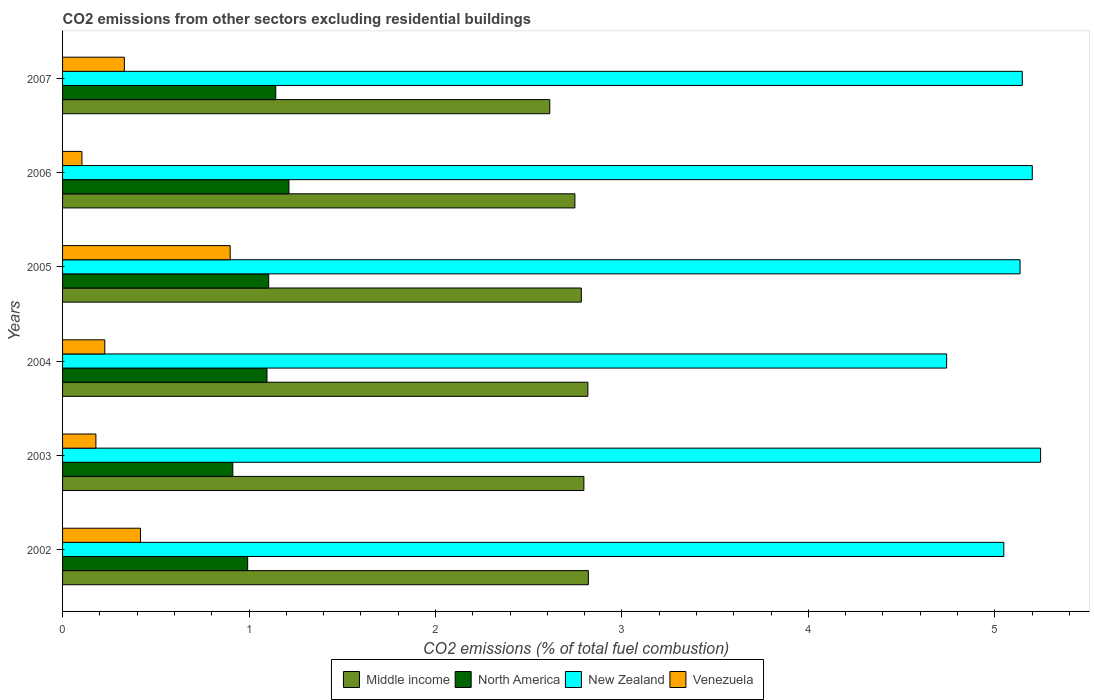How many bars are there on the 5th tick from the bottom?
Give a very brief answer. 4. What is the label of the 1st group of bars from the top?
Your answer should be very brief. 2007. What is the total CO2 emitted in North America in 2006?
Your answer should be very brief. 1.21. Across all years, what is the maximum total CO2 emitted in North America?
Offer a very short reply. 1.21. Across all years, what is the minimum total CO2 emitted in Venezuela?
Ensure brevity in your answer.  0.1. In which year was the total CO2 emitted in Venezuela minimum?
Give a very brief answer. 2006. What is the total total CO2 emitted in Venezuela in the graph?
Provide a succinct answer. 2.16. What is the difference between the total CO2 emitted in Middle income in 2005 and that in 2006?
Your answer should be very brief. 0.03. What is the difference between the total CO2 emitted in Middle income in 2006 and the total CO2 emitted in Venezuela in 2002?
Provide a short and direct response. 2.33. What is the average total CO2 emitted in Venezuela per year?
Offer a terse response. 0.36. In the year 2003, what is the difference between the total CO2 emitted in Venezuela and total CO2 emitted in Middle income?
Make the answer very short. -2.62. In how many years, is the total CO2 emitted in Middle income greater than 4.8 ?
Ensure brevity in your answer.  0. What is the ratio of the total CO2 emitted in New Zealand in 2002 to that in 2003?
Offer a terse response. 0.96. Is the total CO2 emitted in North America in 2003 less than that in 2007?
Make the answer very short. Yes. What is the difference between the highest and the second highest total CO2 emitted in North America?
Give a very brief answer. 0.07. What is the difference between the highest and the lowest total CO2 emitted in North America?
Keep it short and to the point. 0.3. In how many years, is the total CO2 emitted in Venezuela greater than the average total CO2 emitted in Venezuela taken over all years?
Offer a terse response. 2. Is it the case that in every year, the sum of the total CO2 emitted in Venezuela and total CO2 emitted in North America is greater than the sum of total CO2 emitted in Middle income and total CO2 emitted in New Zealand?
Your response must be concise. No. What does the 3rd bar from the top in 2005 represents?
Your answer should be compact. North America. What does the 4th bar from the bottom in 2003 represents?
Your answer should be very brief. Venezuela. Is it the case that in every year, the sum of the total CO2 emitted in Middle income and total CO2 emitted in Venezuela is greater than the total CO2 emitted in North America?
Make the answer very short. Yes. Are the values on the major ticks of X-axis written in scientific E-notation?
Your answer should be compact. No. Does the graph contain any zero values?
Your response must be concise. No. Where does the legend appear in the graph?
Your answer should be compact. Bottom center. How many legend labels are there?
Make the answer very short. 4. How are the legend labels stacked?
Ensure brevity in your answer.  Horizontal. What is the title of the graph?
Ensure brevity in your answer.  CO2 emissions from other sectors excluding residential buildings. What is the label or title of the X-axis?
Offer a terse response. CO2 emissions (% of total fuel combustion). What is the CO2 emissions (% of total fuel combustion) of Middle income in 2002?
Your answer should be compact. 2.82. What is the CO2 emissions (% of total fuel combustion) in North America in 2002?
Provide a short and direct response. 0.99. What is the CO2 emissions (% of total fuel combustion) of New Zealand in 2002?
Your answer should be compact. 5.05. What is the CO2 emissions (% of total fuel combustion) of Venezuela in 2002?
Your answer should be very brief. 0.42. What is the CO2 emissions (% of total fuel combustion) in Middle income in 2003?
Your answer should be very brief. 2.8. What is the CO2 emissions (% of total fuel combustion) in North America in 2003?
Ensure brevity in your answer.  0.91. What is the CO2 emissions (% of total fuel combustion) of New Zealand in 2003?
Offer a terse response. 5.25. What is the CO2 emissions (% of total fuel combustion) of Venezuela in 2003?
Make the answer very short. 0.18. What is the CO2 emissions (% of total fuel combustion) in Middle income in 2004?
Offer a very short reply. 2.82. What is the CO2 emissions (% of total fuel combustion) in North America in 2004?
Your response must be concise. 1.1. What is the CO2 emissions (% of total fuel combustion) in New Zealand in 2004?
Make the answer very short. 4.74. What is the CO2 emissions (% of total fuel combustion) in Venezuela in 2004?
Give a very brief answer. 0.23. What is the CO2 emissions (% of total fuel combustion) of Middle income in 2005?
Your response must be concise. 2.78. What is the CO2 emissions (% of total fuel combustion) of North America in 2005?
Provide a succinct answer. 1.11. What is the CO2 emissions (% of total fuel combustion) of New Zealand in 2005?
Offer a terse response. 5.14. What is the CO2 emissions (% of total fuel combustion) of Venezuela in 2005?
Ensure brevity in your answer.  0.9. What is the CO2 emissions (% of total fuel combustion) in Middle income in 2006?
Your answer should be very brief. 2.75. What is the CO2 emissions (% of total fuel combustion) in North America in 2006?
Provide a short and direct response. 1.21. What is the CO2 emissions (% of total fuel combustion) of New Zealand in 2006?
Your response must be concise. 5.2. What is the CO2 emissions (% of total fuel combustion) of Venezuela in 2006?
Give a very brief answer. 0.1. What is the CO2 emissions (% of total fuel combustion) in Middle income in 2007?
Keep it short and to the point. 2.61. What is the CO2 emissions (% of total fuel combustion) of North America in 2007?
Your answer should be very brief. 1.14. What is the CO2 emissions (% of total fuel combustion) in New Zealand in 2007?
Your answer should be compact. 5.15. What is the CO2 emissions (% of total fuel combustion) in Venezuela in 2007?
Keep it short and to the point. 0.33. Across all years, what is the maximum CO2 emissions (% of total fuel combustion) of Middle income?
Make the answer very short. 2.82. Across all years, what is the maximum CO2 emissions (% of total fuel combustion) in North America?
Provide a short and direct response. 1.21. Across all years, what is the maximum CO2 emissions (% of total fuel combustion) in New Zealand?
Your response must be concise. 5.25. Across all years, what is the maximum CO2 emissions (% of total fuel combustion) of Venezuela?
Your response must be concise. 0.9. Across all years, what is the minimum CO2 emissions (% of total fuel combustion) of Middle income?
Provide a short and direct response. 2.61. Across all years, what is the minimum CO2 emissions (% of total fuel combustion) in North America?
Ensure brevity in your answer.  0.91. Across all years, what is the minimum CO2 emissions (% of total fuel combustion) of New Zealand?
Provide a succinct answer. 4.74. Across all years, what is the minimum CO2 emissions (% of total fuel combustion) in Venezuela?
Provide a succinct answer. 0.1. What is the total CO2 emissions (% of total fuel combustion) in Middle income in the graph?
Provide a succinct answer. 16.58. What is the total CO2 emissions (% of total fuel combustion) of North America in the graph?
Make the answer very short. 6.47. What is the total CO2 emissions (% of total fuel combustion) in New Zealand in the graph?
Your response must be concise. 30.52. What is the total CO2 emissions (% of total fuel combustion) in Venezuela in the graph?
Provide a short and direct response. 2.16. What is the difference between the CO2 emissions (% of total fuel combustion) in Middle income in 2002 and that in 2003?
Your answer should be very brief. 0.02. What is the difference between the CO2 emissions (% of total fuel combustion) in North America in 2002 and that in 2003?
Offer a terse response. 0.08. What is the difference between the CO2 emissions (% of total fuel combustion) of New Zealand in 2002 and that in 2003?
Offer a very short reply. -0.2. What is the difference between the CO2 emissions (% of total fuel combustion) of Venezuela in 2002 and that in 2003?
Ensure brevity in your answer.  0.24. What is the difference between the CO2 emissions (% of total fuel combustion) of Middle income in 2002 and that in 2004?
Give a very brief answer. 0. What is the difference between the CO2 emissions (% of total fuel combustion) in North America in 2002 and that in 2004?
Offer a terse response. -0.1. What is the difference between the CO2 emissions (% of total fuel combustion) in New Zealand in 2002 and that in 2004?
Ensure brevity in your answer.  0.31. What is the difference between the CO2 emissions (% of total fuel combustion) in Venezuela in 2002 and that in 2004?
Your answer should be very brief. 0.19. What is the difference between the CO2 emissions (% of total fuel combustion) in Middle income in 2002 and that in 2005?
Provide a succinct answer. 0.04. What is the difference between the CO2 emissions (% of total fuel combustion) of North America in 2002 and that in 2005?
Make the answer very short. -0.11. What is the difference between the CO2 emissions (% of total fuel combustion) of New Zealand in 2002 and that in 2005?
Keep it short and to the point. -0.09. What is the difference between the CO2 emissions (% of total fuel combustion) of Venezuela in 2002 and that in 2005?
Ensure brevity in your answer.  -0.48. What is the difference between the CO2 emissions (% of total fuel combustion) of Middle income in 2002 and that in 2006?
Make the answer very short. 0.07. What is the difference between the CO2 emissions (% of total fuel combustion) in North America in 2002 and that in 2006?
Your answer should be compact. -0.22. What is the difference between the CO2 emissions (% of total fuel combustion) in New Zealand in 2002 and that in 2006?
Make the answer very short. -0.15. What is the difference between the CO2 emissions (% of total fuel combustion) in Venezuela in 2002 and that in 2006?
Provide a succinct answer. 0.31. What is the difference between the CO2 emissions (% of total fuel combustion) in Middle income in 2002 and that in 2007?
Offer a terse response. 0.21. What is the difference between the CO2 emissions (% of total fuel combustion) in North America in 2002 and that in 2007?
Your answer should be very brief. -0.15. What is the difference between the CO2 emissions (% of total fuel combustion) in New Zealand in 2002 and that in 2007?
Keep it short and to the point. -0.1. What is the difference between the CO2 emissions (% of total fuel combustion) in Venezuela in 2002 and that in 2007?
Give a very brief answer. 0.09. What is the difference between the CO2 emissions (% of total fuel combustion) of Middle income in 2003 and that in 2004?
Your answer should be very brief. -0.02. What is the difference between the CO2 emissions (% of total fuel combustion) of North America in 2003 and that in 2004?
Offer a very short reply. -0.18. What is the difference between the CO2 emissions (% of total fuel combustion) of New Zealand in 2003 and that in 2004?
Make the answer very short. 0.5. What is the difference between the CO2 emissions (% of total fuel combustion) of Venezuela in 2003 and that in 2004?
Keep it short and to the point. -0.05. What is the difference between the CO2 emissions (% of total fuel combustion) of Middle income in 2003 and that in 2005?
Give a very brief answer. 0.01. What is the difference between the CO2 emissions (% of total fuel combustion) in North America in 2003 and that in 2005?
Offer a very short reply. -0.19. What is the difference between the CO2 emissions (% of total fuel combustion) of New Zealand in 2003 and that in 2005?
Give a very brief answer. 0.11. What is the difference between the CO2 emissions (% of total fuel combustion) of Venezuela in 2003 and that in 2005?
Provide a short and direct response. -0.72. What is the difference between the CO2 emissions (% of total fuel combustion) in Middle income in 2003 and that in 2006?
Keep it short and to the point. 0.05. What is the difference between the CO2 emissions (% of total fuel combustion) of North America in 2003 and that in 2006?
Ensure brevity in your answer.  -0.3. What is the difference between the CO2 emissions (% of total fuel combustion) of New Zealand in 2003 and that in 2006?
Offer a very short reply. 0.04. What is the difference between the CO2 emissions (% of total fuel combustion) in Venezuela in 2003 and that in 2006?
Offer a very short reply. 0.07. What is the difference between the CO2 emissions (% of total fuel combustion) of Middle income in 2003 and that in 2007?
Provide a succinct answer. 0.18. What is the difference between the CO2 emissions (% of total fuel combustion) of North America in 2003 and that in 2007?
Give a very brief answer. -0.23. What is the difference between the CO2 emissions (% of total fuel combustion) of New Zealand in 2003 and that in 2007?
Make the answer very short. 0.1. What is the difference between the CO2 emissions (% of total fuel combustion) of Venezuela in 2003 and that in 2007?
Your answer should be compact. -0.15. What is the difference between the CO2 emissions (% of total fuel combustion) of Middle income in 2004 and that in 2005?
Provide a short and direct response. 0.04. What is the difference between the CO2 emissions (% of total fuel combustion) of North America in 2004 and that in 2005?
Keep it short and to the point. -0.01. What is the difference between the CO2 emissions (% of total fuel combustion) in New Zealand in 2004 and that in 2005?
Keep it short and to the point. -0.39. What is the difference between the CO2 emissions (% of total fuel combustion) in Venezuela in 2004 and that in 2005?
Offer a very short reply. -0.67. What is the difference between the CO2 emissions (% of total fuel combustion) in Middle income in 2004 and that in 2006?
Keep it short and to the point. 0.07. What is the difference between the CO2 emissions (% of total fuel combustion) in North America in 2004 and that in 2006?
Provide a short and direct response. -0.12. What is the difference between the CO2 emissions (% of total fuel combustion) of New Zealand in 2004 and that in 2006?
Offer a terse response. -0.46. What is the difference between the CO2 emissions (% of total fuel combustion) of Venezuela in 2004 and that in 2006?
Provide a short and direct response. 0.12. What is the difference between the CO2 emissions (% of total fuel combustion) in Middle income in 2004 and that in 2007?
Keep it short and to the point. 0.2. What is the difference between the CO2 emissions (% of total fuel combustion) in North America in 2004 and that in 2007?
Your answer should be very brief. -0.05. What is the difference between the CO2 emissions (% of total fuel combustion) in New Zealand in 2004 and that in 2007?
Offer a very short reply. -0.41. What is the difference between the CO2 emissions (% of total fuel combustion) of Venezuela in 2004 and that in 2007?
Provide a short and direct response. -0.1. What is the difference between the CO2 emissions (% of total fuel combustion) in Middle income in 2005 and that in 2006?
Give a very brief answer. 0.03. What is the difference between the CO2 emissions (% of total fuel combustion) in North America in 2005 and that in 2006?
Keep it short and to the point. -0.11. What is the difference between the CO2 emissions (% of total fuel combustion) in New Zealand in 2005 and that in 2006?
Your answer should be very brief. -0.07. What is the difference between the CO2 emissions (% of total fuel combustion) of Venezuela in 2005 and that in 2006?
Give a very brief answer. 0.8. What is the difference between the CO2 emissions (% of total fuel combustion) of Middle income in 2005 and that in 2007?
Your answer should be compact. 0.17. What is the difference between the CO2 emissions (% of total fuel combustion) in North America in 2005 and that in 2007?
Your answer should be compact. -0.04. What is the difference between the CO2 emissions (% of total fuel combustion) in New Zealand in 2005 and that in 2007?
Provide a succinct answer. -0.01. What is the difference between the CO2 emissions (% of total fuel combustion) in Venezuela in 2005 and that in 2007?
Offer a terse response. 0.57. What is the difference between the CO2 emissions (% of total fuel combustion) in Middle income in 2006 and that in 2007?
Make the answer very short. 0.13. What is the difference between the CO2 emissions (% of total fuel combustion) of North America in 2006 and that in 2007?
Keep it short and to the point. 0.07. What is the difference between the CO2 emissions (% of total fuel combustion) of New Zealand in 2006 and that in 2007?
Provide a short and direct response. 0.05. What is the difference between the CO2 emissions (% of total fuel combustion) of Venezuela in 2006 and that in 2007?
Your response must be concise. -0.23. What is the difference between the CO2 emissions (% of total fuel combustion) in Middle income in 2002 and the CO2 emissions (% of total fuel combustion) in North America in 2003?
Provide a succinct answer. 1.91. What is the difference between the CO2 emissions (% of total fuel combustion) in Middle income in 2002 and the CO2 emissions (% of total fuel combustion) in New Zealand in 2003?
Your response must be concise. -2.43. What is the difference between the CO2 emissions (% of total fuel combustion) in Middle income in 2002 and the CO2 emissions (% of total fuel combustion) in Venezuela in 2003?
Your response must be concise. 2.64. What is the difference between the CO2 emissions (% of total fuel combustion) of North America in 2002 and the CO2 emissions (% of total fuel combustion) of New Zealand in 2003?
Your answer should be very brief. -4.25. What is the difference between the CO2 emissions (% of total fuel combustion) of North America in 2002 and the CO2 emissions (% of total fuel combustion) of Venezuela in 2003?
Ensure brevity in your answer.  0.81. What is the difference between the CO2 emissions (% of total fuel combustion) in New Zealand in 2002 and the CO2 emissions (% of total fuel combustion) in Venezuela in 2003?
Provide a short and direct response. 4.87. What is the difference between the CO2 emissions (% of total fuel combustion) of Middle income in 2002 and the CO2 emissions (% of total fuel combustion) of North America in 2004?
Offer a terse response. 1.72. What is the difference between the CO2 emissions (% of total fuel combustion) of Middle income in 2002 and the CO2 emissions (% of total fuel combustion) of New Zealand in 2004?
Ensure brevity in your answer.  -1.92. What is the difference between the CO2 emissions (% of total fuel combustion) of Middle income in 2002 and the CO2 emissions (% of total fuel combustion) of Venezuela in 2004?
Provide a short and direct response. 2.59. What is the difference between the CO2 emissions (% of total fuel combustion) in North America in 2002 and the CO2 emissions (% of total fuel combustion) in New Zealand in 2004?
Keep it short and to the point. -3.75. What is the difference between the CO2 emissions (% of total fuel combustion) in North America in 2002 and the CO2 emissions (% of total fuel combustion) in Venezuela in 2004?
Offer a very short reply. 0.77. What is the difference between the CO2 emissions (% of total fuel combustion) in New Zealand in 2002 and the CO2 emissions (% of total fuel combustion) in Venezuela in 2004?
Your answer should be very brief. 4.82. What is the difference between the CO2 emissions (% of total fuel combustion) of Middle income in 2002 and the CO2 emissions (% of total fuel combustion) of North America in 2005?
Provide a short and direct response. 1.71. What is the difference between the CO2 emissions (% of total fuel combustion) of Middle income in 2002 and the CO2 emissions (% of total fuel combustion) of New Zealand in 2005?
Keep it short and to the point. -2.32. What is the difference between the CO2 emissions (% of total fuel combustion) in Middle income in 2002 and the CO2 emissions (% of total fuel combustion) in Venezuela in 2005?
Make the answer very short. 1.92. What is the difference between the CO2 emissions (% of total fuel combustion) in North America in 2002 and the CO2 emissions (% of total fuel combustion) in New Zealand in 2005?
Your answer should be compact. -4.14. What is the difference between the CO2 emissions (% of total fuel combustion) of North America in 2002 and the CO2 emissions (% of total fuel combustion) of Venezuela in 2005?
Your response must be concise. 0.09. What is the difference between the CO2 emissions (% of total fuel combustion) in New Zealand in 2002 and the CO2 emissions (% of total fuel combustion) in Venezuela in 2005?
Ensure brevity in your answer.  4.15. What is the difference between the CO2 emissions (% of total fuel combustion) in Middle income in 2002 and the CO2 emissions (% of total fuel combustion) in North America in 2006?
Make the answer very short. 1.61. What is the difference between the CO2 emissions (% of total fuel combustion) in Middle income in 2002 and the CO2 emissions (% of total fuel combustion) in New Zealand in 2006?
Provide a short and direct response. -2.38. What is the difference between the CO2 emissions (% of total fuel combustion) in Middle income in 2002 and the CO2 emissions (% of total fuel combustion) in Venezuela in 2006?
Your answer should be compact. 2.72. What is the difference between the CO2 emissions (% of total fuel combustion) in North America in 2002 and the CO2 emissions (% of total fuel combustion) in New Zealand in 2006?
Offer a terse response. -4.21. What is the difference between the CO2 emissions (% of total fuel combustion) in New Zealand in 2002 and the CO2 emissions (% of total fuel combustion) in Venezuela in 2006?
Provide a succinct answer. 4.94. What is the difference between the CO2 emissions (% of total fuel combustion) in Middle income in 2002 and the CO2 emissions (% of total fuel combustion) in North America in 2007?
Give a very brief answer. 1.68. What is the difference between the CO2 emissions (% of total fuel combustion) of Middle income in 2002 and the CO2 emissions (% of total fuel combustion) of New Zealand in 2007?
Offer a very short reply. -2.33. What is the difference between the CO2 emissions (% of total fuel combustion) in Middle income in 2002 and the CO2 emissions (% of total fuel combustion) in Venezuela in 2007?
Your answer should be compact. 2.49. What is the difference between the CO2 emissions (% of total fuel combustion) in North America in 2002 and the CO2 emissions (% of total fuel combustion) in New Zealand in 2007?
Ensure brevity in your answer.  -4.15. What is the difference between the CO2 emissions (% of total fuel combustion) of North America in 2002 and the CO2 emissions (% of total fuel combustion) of Venezuela in 2007?
Ensure brevity in your answer.  0.66. What is the difference between the CO2 emissions (% of total fuel combustion) of New Zealand in 2002 and the CO2 emissions (% of total fuel combustion) of Venezuela in 2007?
Provide a succinct answer. 4.72. What is the difference between the CO2 emissions (% of total fuel combustion) in Middle income in 2003 and the CO2 emissions (% of total fuel combustion) in North America in 2004?
Provide a succinct answer. 1.7. What is the difference between the CO2 emissions (% of total fuel combustion) in Middle income in 2003 and the CO2 emissions (% of total fuel combustion) in New Zealand in 2004?
Offer a very short reply. -1.95. What is the difference between the CO2 emissions (% of total fuel combustion) in Middle income in 2003 and the CO2 emissions (% of total fuel combustion) in Venezuela in 2004?
Provide a succinct answer. 2.57. What is the difference between the CO2 emissions (% of total fuel combustion) of North America in 2003 and the CO2 emissions (% of total fuel combustion) of New Zealand in 2004?
Give a very brief answer. -3.83. What is the difference between the CO2 emissions (% of total fuel combustion) in North America in 2003 and the CO2 emissions (% of total fuel combustion) in Venezuela in 2004?
Your response must be concise. 0.69. What is the difference between the CO2 emissions (% of total fuel combustion) of New Zealand in 2003 and the CO2 emissions (% of total fuel combustion) of Venezuela in 2004?
Ensure brevity in your answer.  5.02. What is the difference between the CO2 emissions (% of total fuel combustion) in Middle income in 2003 and the CO2 emissions (% of total fuel combustion) in North America in 2005?
Offer a terse response. 1.69. What is the difference between the CO2 emissions (% of total fuel combustion) of Middle income in 2003 and the CO2 emissions (% of total fuel combustion) of New Zealand in 2005?
Your answer should be very brief. -2.34. What is the difference between the CO2 emissions (% of total fuel combustion) of Middle income in 2003 and the CO2 emissions (% of total fuel combustion) of Venezuela in 2005?
Ensure brevity in your answer.  1.9. What is the difference between the CO2 emissions (% of total fuel combustion) of North America in 2003 and the CO2 emissions (% of total fuel combustion) of New Zealand in 2005?
Make the answer very short. -4.22. What is the difference between the CO2 emissions (% of total fuel combustion) in North America in 2003 and the CO2 emissions (% of total fuel combustion) in Venezuela in 2005?
Provide a short and direct response. 0.01. What is the difference between the CO2 emissions (% of total fuel combustion) of New Zealand in 2003 and the CO2 emissions (% of total fuel combustion) of Venezuela in 2005?
Keep it short and to the point. 4.35. What is the difference between the CO2 emissions (% of total fuel combustion) in Middle income in 2003 and the CO2 emissions (% of total fuel combustion) in North America in 2006?
Offer a terse response. 1.58. What is the difference between the CO2 emissions (% of total fuel combustion) of Middle income in 2003 and the CO2 emissions (% of total fuel combustion) of New Zealand in 2006?
Provide a short and direct response. -2.41. What is the difference between the CO2 emissions (% of total fuel combustion) in Middle income in 2003 and the CO2 emissions (% of total fuel combustion) in Venezuela in 2006?
Provide a succinct answer. 2.69. What is the difference between the CO2 emissions (% of total fuel combustion) of North America in 2003 and the CO2 emissions (% of total fuel combustion) of New Zealand in 2006?
Ensure brevity in your answer.  -4.29. What is the difference between the CO2 emissions (% of total fuel combustion) of North America in 2003 and the CO2 emissions (% of total fuel combustion) of Venezuela in 2006?
Offer a very short reply. 0.81. What is the difference between the CO2 emissions (% of total fuel combustion) of New Zealand in 2003 and the CO2 emissions (% of total fuel combustion) of Venezuela in 2006?
Ensure brevity in your answer.  5.14. What is the difference between the CO2 emissions (% of total fuel combustion) of Middle income in 2003 and the CO2 emissions (% of total fuel combustion) of North America in 2007?
Your answer should be compact. 1.65. What is the difference between the CO2 emissions (% of total fuel combustion) of Middle income in 2003 and the CO2 emissions (% of total fuel combustion) of New Zealand in 2007?
Provide a short and direct response. -2.35. What is the difference between the CO2 emissions (% of total fuel combustion) of Middle income in 2003 and the CO2 emissions (% of total fuel combustion) of Venezuela in 2007?
Your response must be concise. 2.46. What is the difference between the CO2 emissions (% of total fuel combustion) of North America in 2003 and the CO2 emissions (% of total fuel combustion) of New Zealand in 2007?
Offer a terse response. -4.23. What is the difference between the CO2 emissions (% of total fuel combustion) of North America in 2003 and the CO2 emissions (% of total fuel combustion) of Venezuela in 2007?
Offer a terse response. 0.58. What is the difference between the CO2 emissions (% of total fuel combustion) of New Zealand in 2003 and the CO2 emissions (% of total fuel combustion) of Venezuela in 2007?
Ensure brevity in your answer.  4.91. What is the difference between the CO2 emissions (% of total fuel combustion) in Middle income in 2004 and the CO2 emissions (% of total fuel combustion) in North America in 2005?
Give a very brief answer. 1.71. What is the difference between the CO2 emissions (% of total fuel combustion) of Middle income in 2004 and the CO2 emissions (% of total fuel combustion) of New Zealand in 2005?
Provide a succinct answer. -2.32. What is the difference between the CO2 emissions (% of total fuel combustion) of Middle income in 2004 and the CO2 emissions (% of total fuel combustion) of Venezuela in 2005?
Your answer should be compact. 1.92. What is the difference between the CO2 emissions (% of total fuel combustion) of North America in 2004 and the CO2 emissions (% of total fuel combustion) of New Zealand in 2005?
Your answer should be compact. -4.04. What is the difference between the CO2 emissions (% of total fuel combustion) of North America in 2004 and the CO2 emissions (% of total fuel combustion) of Venezuela in 2005?
Make the answer very short. 0.2. What is the difference between the CO2 emissions (% of total fuel combustion) of New Zealand in 2004 and the CO2 emissions (% of total fuel combustion) of Venezuela in 2005?
Provide a short and direct response. 3.84. What is the difference between the CO2 emissions (% of total fuel combustion) in Middle income in 2004 and the CO2 emissions (% of total fuel combustion) in North America in 2006?
Keep it short and to the point. 1.6. What is the difference between the CO2 emissions (% of total fuel combustion) of Middle income in 2004 and the CO2 emissions (% of total fuel combustion) of New Zealand in 2006?
Offer a terse response. -2.38. What is the difference between the CO2 emissions (% of total fuel combustion) in Middle income in 2004 and the CO2 emissions (% of total fuel combustion) in Venezuela in 2006?
Make the answer very short. 2.71. What is the difference between the CO2 emissions (% of total fuel combustion) of North America in 2004 and the CO2 emissions (% of total fuel combustion) of New Zealand in 2006?
Ensure brevity in your answer.  -4.1. What is the difference between the CO2 emissions (% of total fuel combustion) in North America in 2004 and the CO2 emissions (% of total fuel combustion) in Venezuela in 2006?
Your answer should be very brief. 0.99. What is the difference between the CO2 emissions (% of total fuel combustion) of New Zealand in 2004 and the CO2 emissions (% of total fuel combustion) of Venezuela in 2006?
Make the answer very short. 4.64. What is the difference between the CO2 emissions (% of total fuel combustion) in Middle income in 2004 and the CO2 emissions (% of total fuel combustion) in North America in 2007?
Provide a succinct answer. 1.67. What is the difference between the CO2 emissions (% of total fuel combustion) of Middle income in 2004 and the CO2 emissions (% of total fuel combustion) of New Zealand in 2007?
Make the answer very short. -2.33. What is the difference between the CO2 emissions (% of total fuel combustion) in Middle income in 2004 and the CO2 emissions (% of total fuel combustion) in Venezuela in 2007?
Ensure brevity in your answer.  2.49. What is the difference between the CO2 emissions (% of total fuel combustion) in North America in 2004 and the CO2 emissions (% of total fuel combustion) in New Zealand in 2007?
Provide a short and direct response. -4.05. What is the difference between the CO2 emissions (% of total fuel combustion) in North America in 2004 and the CO2 emissions (% of total fuel combustion) in Venezuela in 2007?
Your answer should be compact. 0.77. What is the difference between the CO2 emissions (% of total fuel combustion) in New Zealand in 2004 and the CO2 emissions (% of total fuel combustion) in Venezuela in 2007?
Offer a very short reply. 4.41. What is the difference between the CO2 emissions (% of total fuel combustion) of Middle income in 2005 and the CO2 emissions (% of total fuel combustion) of North America in 2006?
Make the answer very short. 1.57. What is the difference between the CO2 emissions (% of total fuel combustion) of Middle income in 2005 and the CO2 emissions (% of total fuel combustion) of New Zealand in 2006?
Offer a terse response. -2.42. What is the difference between the CO2 emissions (% of total fuel combustion) of Middle income in 2005 and the CO2 emissions (% of total fuel combustion) of Venezuela in 2006?
Give a very brief answer. 2.68. What is the difference between the CO2 emissions (% of total fuel combustion) of North America in 2005 and the CO2 emissions (% of total fuel combustion) of New Zealand in 2006?
Offer a very short reply. -4.1. What is the difference between the CO2 emissions (% of total fuel combustion) in North America in 2005 and the CO2 emissions (% of total fuel combustion) in Venezuela in 2006?
Ensure brevity in your answer.  1. What is the difference between the CO2 emissions (% of total fuel combustion) in New Zealand in 2005 and the CO2 emissions (% of total fuel combustion) in Venezuela in 2006?
Offer a very short reply. 5.03. What is the difference between the CO2 emissions (% of total fuel combustion) of Middle income in 2005 and the CO2 emissions (% of total fuel combustion) of North America in 2007?
Ensure brevity in your answer.  1.64. What is the difference between the CO2 emissions (% of total fuel combustion) of Middle income in 2005 and the CO2 emissions (% of total fuel combustion) of New Zealand in 2007?
Offer a terse response. -2.37. What is the difference between the CO2 emissions (% of total fuel combustion) of Middle income in 2005 and the CO2 emissions (% of total fuel combustion) of Venezuela in 2007?
Offer a terse response. 2.45. What is the difference between the CO2 emissions (% of total fuel combustion) of North America in 2005 and the CO2 emissions (% of total fuel combustion) of New Zealand in 2007?
Give a very brief answer. -4.04. What is the difference between the CO2 emissions (% of total fuel combustion) of North America in 2005 and the CO2 emissions (% of total fuel combustion) of Venezuela in 2007?
Offer a terse response. 0.77. What is the difference between the CO2 emissions (% of total fuel combustion) in New Zealand in 2005 and the CO2 emissions (% of total fuel combustion) in Venezuela in 2007?
Offer a very short reply. 4.8. What is the difference between the CO2 emissions (% of total fuel combustion) of Middle income in 2006 and the CO2 emissions (% of total fuel combustion) of North America in 2007?
Your answer should be very brief. 1.6. What is the difference between the CO2 emissions (% of total fuel combustion) of Middle income in 2006 and the CO2 emissions (% of total fuel combustion) of New Zealand in 2007?
Your answer should be compact. -2.4. What is the difference between the CO2 emissions (% of total fuel combustion) in Middle income in 2006 and the CO2 emissions (% of total fuel combustion) in Venezuela in 2007?
Provide a succinct answer. 2.42. What is the difference between the CO2 emissions (% of total fuel combustion) in North America in 2006 and the CO2 emissions (% of total fuel combustion) in New Zealand in 2007?
Provide a succinct answer. -3.93. What is the difference between the CO2 emissions (% of total fuel combustion) of North America in 2006 and the CO2 emissions (% of total fuel combustion) of Venezuela in 2007?
Make the answer very short. 0.88. What is the difference between the CO2 emissions (% of total fuel combustion) in New Zealand in 2006 and the CO2 emissions (% of total fuel combustion) in Venezuela in 2007?
Offer a terse response. 4.87. What is the average CO2 emissions (% of total fuel combustion) of Middle income per year?
Keep it short and to the point. 2.76. What is the average CO2 emissions (% of total fuel combustion) of North America per year?
Provide a succinct answer. 1.08. What is the average CO2 emissions (% of total fuel combustion) of New Zealand per year?
Offer a terse response. 5.09. What is the average CO2 emissions (% of total fuel combustion) of Venezuela per year?
Make the answer very short. 0.36. In the year 2002, what is the difference between the CO2 emissions (% of total fuel combustion) of Middle income and CO2 emissions (% of total fuel combustion) of North America?
Make the answer very short. 1.83. In the year 2002, what is the difference between the CO2 emissions (% of total fuel combustion) of Middle income and CO2 emissions (% of total fuel combustion) of New Zealand?
Make the answer very short. -2.23. In the year 2002, what is the difference between the CO2 emissions (% of total fuel combustion) in Middle income and CO2 emissions (% of total fuel combustion) in Venezuela?
Offer a terse response. 2.4. In the year 2002, what is the difference between the CO2 emissions (% of total fuel combustion) of North America and CO2 emissions (% of total fuel combustion) of New Zealand?
Offer a terse response. -4.06. In the year 2002, what is the difference between the CO2 emissions (% of total fuel combustion) of North America and CO2 emissions (% of total fuel combustion) of Venezuela?
Offer a very short reply. 0.57. In the year 2002, what is the difference between the CO2 emissions (% of total fuel combustion) of New Zealand and CO2 emissions (% of total fuel combustion) of Venezuela?
Make the answer very short. 4.63. In the year 2003, what is the difference between the CO2 emissions (% of total fuel combustion) in Middle income and CO2 emissions (% of total fuel combustion) in North America?
Keep it short and to the point. 1.88. In the year 2003, what is the difference between the CO2 emissions (% of total fuel combustion) of Middle income and CO2 emissions (% of total fuel combustion) of New Zealand?
Provide a succinct answer. -2.45. In the year 2003, what is the difference between the CO2 emissions (% of total fuel combustion) of Middle income and CO2 emissions (% of total fuel combustion) of Venezuela?
Ensure brevity in your answer.  2.62. In the year 2003, what is the difference between the CO2 emissions (% of total fuel combustion) in North America and CO2 emissions (% of total fuel combustion) in New Zealand?
Your answer should be very brief. -4.33. In the year 2003, what is the difference between the CO2 emissions (% of total fuel combustion) of North America and CO2 emissions (% of total fuel combustion) of Venezuela?
Make the answer very short. 0.73. In the year 2003, what is the difference between the CO2 emissions (% of total fuel combustion) of New Zealand and CO2 emissions (% of total fuel combustion) of Venezuela?
Your answer should be compact. 5.07. In the year 2004, what is the difference between the CO2 emissions (% of total fuel combustion) of Middle income and CO2 emissions (% of total fuel combustion) of North America?
Make the answer very short. 1.72. In the year 2004, what is the difference between the CO2 emissions (% of total fuel combustion) of Middle income and CO2 emissions (% of total fuel combustion) of New Zealand?
Give a very brief answer. -1.92. In the year 2004, what is the difference between the CO2 emissions (% of total fuel combustion) in Middle income and CO2 emissions (% of total fuel combustion) in Venezuela?
Offer a very short reply. 2.59. In the year 2004, what is the difference between the CO2 emissions (% of total fuel combustion) of North America and CO2 emissions (% of total fuel combustion) of New Zealand?
Your answer should be compact. -3.65. In the year 2004, what is the difference between the CO2 emissions (% of total fuel combustion) of North America and CO2 emissions (% of total fuel combustion) of Venezuela?
Your answer should be compact. 0.87. In the year 2004, what is the difference between the CO2 emissions (% of total fuel combustion) of New Zealand and CO2 emissions (% of total fuel combustion) of Venezuela?
Provide a short and direct response. 4.52. In the year 2005, what is the difference between the CO2 emissions (% of total fuel combustion) of Middle income and CO2 emissions (% of total fuel combustion) of North America?
Keep it short and to the point. 1.68. In the year 2005, what is the difference between the CO2 emissions (% of total fuel combustion) of Middle income and CO2 emissions (% of total fuel combustion) of New Zealand?
Ensure brevity in your answer.  -2.35. In the year 2005, what is the difference between the CO2 emissions (% of total fuel combustion) of Middle income and CO2 emissions (% of total fuel combustion) of Venezuela?
Your answer should be compact. 1.88. In the year 2005, what is the difference between the CO2 emissions (% of total fuel combustion) in North America and CO2 emissions (% of total fuel combustion) in New Zealand?
Make the answer very short. -4.03. In the year 2005, what is the difference between the CO2 emissions (% of total fuel combustion) in North America and CO2 emissions (% of total fuel combustion) in Venezuela?
Provide a succinct answer. 0.21. In the year 2005, what is the difference between the CO2 emissions (% of total fuel combustion) of New Zealand and CO2 emissions (% of total fuel combustion) of Venezuela?
Provide a succinct answer. 4.24. In the year 2006, what is the difference between the CO2 emissions (% of total fuel combustion) of Middle income and CO2 emissions (% of total fuel combustion) of North America?
Ensure brevity in your answer.  1.53. In the year 2006, what is the difference between the CO2 emissions (% of total fuel combustion) in Middle income and CO2 emissions (% of total fuel combustion) in New Zealand?
Your answer should be very brief. -2.45. In the year 2006, what is the difference between the CO2 emissions (% of total fuel combustion) of Middle income and CO2 emissions (% of total fuel combustion) of Venezuela?
Your answer should be compact. 2.64. In the year 2006, what is the difference between the CO2 emissions (% of total fuel combustion) of North America and CO2 emissions (% of total fuel combustion) of New Zealand?
Your response must be concise. -3.99. In the year 2006, what is the difference between the CO2 emissions (% of total fuel combustion) of North America and CO2 emissions (% of total fuel combustion) of Venezuela?
Offer a terse response. 1.11. In the year 2006, what is the difference between the CO2 emissions (% of total fuel combustion) in New Zealand and CO2 emissions (% of total fuel combustion) in Venezuela?
Keep it short and to the point. 5.1. In the year 2007, what is the difference between the CO2 emissions (% of total fuel combustion) in Middle income and CO2 emissions (% of total fuel combustion) in North America?
Provide a short and direct response. 1.47. In the year 2007, what is the difference between the CO2 emissions (% of total fuel combustion) of Middle income and CO2 emissions (% of total fuel combustion) of New Zealand?
Your answer should be very brief. -2.53. In the year 2007, what is the difference between the CO2 emissions (% of total fuel combustion) in Middle income and CO2 emissions (% of total fuel combustion) in Venezuela?
Your answer should be very brief. 2.28. In the year 2007, what is the difference between the CO2 emissions (% of total fuel combustion) of North America and CO2 emissions (% of total fuel combustion) of New Zealand?
Provide a short and direct response. -4. In the year 2007, what is the difference between the CO2 emissions (% of total fuel combustion) of North America and CO2 emissions (% of total fuel combustion) of Venezuela?
Offer a very short reply. 0.81. In the year 2007, what is the difference between the CO2 emissions (% of total fuel combustion) in New Zealand and CO2 emissions (% of total fuel combustion) in Venezuela?
Provide a short and direct response. 4.82. What is the ratio of the CO2 emissions (% of total fuel combustion) of Middle income in 2002 to that in 2003?
Provide a succinct answer. 1.01. What is the ratio of the CO2 emissions (% of total fuel combustion) of North America in 2002 to that in 2003?
Give a very brief answer. 1.09. What is the ratio of the CO2 emissions (% of total fuel combustion) of New Zealand in 2002 to that in 2003?
Give a very brief answer. 0.96. What is the ratio of the CO2 emissions (% of total fuel combustion) of Venezuela in 2002 to that in 2003?
Give a very brief answer. 2.34. What is the ratio of the CO2 emissions (% of total fuel combustion) in Middle income in 2002 to that in 2004?
Offer a very short reply. 1. What is the ratio of the CO2 emissions (% of total fuel combustion) of North America in 2002 to that in 2004?
Ensure brevity in your answer.  0.91. What is the ratio of the CO2 emissions (% of total fuel combustion) of New Zealand in 2002 to that in 2004?
Your response must be concise. 1.06. What is the ratio of the CO2 emissions (% of total fuel combustion) of Venezuela in 2002 to that in 2004?
Give a very brief answer. 1.85. What is the ratio of the CO2 emissions (% of total fuel combustion) of Middle income in 2002 to that in 2005?
Give a very brief answer. 1.01. What is the ratio of the CO2 emissions (% of total fuel combustion) of North America in 2002 to that in 2005?
Make the answer very short. 0.9. What is the ratio of the CO2 emissions (% of total fuel combustion) of Venezuela in 2002 to that in 2005?
Your response must be concise. 0.47. What is the ratio of the CO2 emissions (% of total fuel combustion) of Middle income in 2002 to that in 2006?
Your response must be concise. 1.03. What is the ratio of the CO2 emissions (% of total fuel combustion) of North America in 2002 to that in 2006?
Your answer should be very brief. 0.82. What is the ratio of the CO2 emissions (% of total fuel combustion) of New Zealand in 2002 to that in 2006?
Keep it short and to the point. 0.97. What is the ratio of the CO2 emissions (% of total fuel combustion) in Venezuela in 2002 to that in 2006?
Provide a short and direct response. 4.02. What is the ratio of the CO2 emissions (% of total fuel combustion) in Middle income in 2002 to that in 2007?
Make the answer very short. 1.08. What is the ratio of the CO2 emissions (% of total fuel combustion) in North America in 2002 to that in 2007?
Provide a short and direct response. 0.87. What is the ratio of the CO2 emissions (% of total fuel combustion) in New Zealand in 2002 to that in 2007?
Give a very brief answer. 0.98. What is the ratio of the CO2 emissions (% of total fuel combustion) of Venezuela in 2002 to that in 2007?
Offer a very short reply. 1.26. What is the ratio of the CO2 emissions (% of total fuel combustion) in North America in 2003 to that in 2004?
Offer a terse response. 0.83. What is the ratio of the CO2 emissions (% of total fuel combustion) in New Zealand in 2003 to that in 2004?
Offer a terse response. 1.11. What is the ratio of the CO2 emissions (% of total fuel combustion) of Venezuela in 2003 to that in 2004?
Provide a succinct answer. 0.79. What is the ratio of the CO2 emissions (% of total fuel combustion) in Middle income in 2003 to that in 2005?
Provide a succinct answer. 1. What is the ratio of the CO2 emissions (% of total fuel combustion) in North America in 2003 to that in 2005?
Give a very brief answer. 0.83. What is the ratio of the CO2 emissions (% of total fuel combustion) of New Zealand in 2003 to that in 2005?
Keep it short and to the point. 1.02. What is the ratio of the CO2 emissions (% of total fuel combustion) of Venezuela in 2003 to that in 2005?
Your answer should be very brief. 0.2. What is the ratio of the CO2 emissions (% of total fuel combustion) in Middle income in 2003 to that in 2006?
Keep it short and to the point. 1.02. What is the ratio of the CO2 emissions (% of total fuel combustion) of North America in 2003 to that in 2006?
Give a very brief answer. 0.75. What is the ratio of the CO2 emissions (% of total fuel combustion) in New Zealand in 2003 to that in 2006?
Offer a very short reply. 1.01. What is the ratio of the CO2 emissions (% of total fuel combustion) in Venezuela in 2003 to that in 2006?
Keep it short and to the point. 1.72. What is the ratio of the CO2 emissions (% of total fuel combustion) in Middle income in 2003 to that in 2007?
Offer a very short reply. 1.07. What is the ratio of the CO2 emissions (% of total fuel combustion) of North America in 2003 to that in 2007?
Your answer should be compact. 0.8. What is the ratio of the CO2 emissions (% of total fuel combustion) in New Zealand in 2003 to that in 2007?
Offer a terse response. 1.02. What is the ratio of the CO2 emissions (% of total fuel combustion) in Venezuela in 2003 to that in 2007?
Ensure brevity in your answer.  0.54. What is the ratio of the CO2 emissions (% of total fuel combustion) in Middle income in 2004 to that in 2005?
Offer a very short reply. 1.01. What is the ratio of the CO2 emissions (% of total fuel combustion) of North America in 2004 to that in 2005?
Your answer should be very brief. 0.99. What is the ratio of the CO2 emissions (% of total fuel combustion) in New Zealand in 2004 to that in 2005?
Give a very brief answer. 0.92. What is the ratio of the CO2 emissions (% of total fuel combustion) of Venezuela in 2004 to that in 2005?
Give a very brief answer. 0.25. What is the ratio of the CO2 emissions (% of total fuel combustion) in Middle income in 2004 to that in 2006?
Make the answer very short. 1.03. What is the ratio of the CO2 emissions (% of total fuel combustion) of North America in 2004 to that in 2006?
Give a very brief answer. 0.9. What is the ratio of the CO2 emissions (% of total fuel combustion) of New Zealand in 2004 to that in 2006?
Your answer should be compact. 0.91. What is the ratio of the CO2 emissions (% of total fuel combustion) of Venezuela in 2004 to that in 2006?
Give a very brief answer. 2.18. What is the ratio of the CO2 emissions (% of total fuel combustion) in Middle income in 2004 to that in 2007?
Your response must be concise. 1.08. What is the ratio of the CO2 emissions (% of total fuel combustion) of North America in 2004 to that in 2007?
Provide a short and direct response. 0.96. What is the ratio of the CO2 emissions (% of total fuel combustion) in New Zealand in 2004 to that in 2007?
Keep it short and to the point. 0.92. What is the ratio of the CO2 emissions (% of total fuel combustion) in Venezuela in 2004 to that in 2007?
Your answer should be compact. 0.68. What is the ratio of the CO2 emissions (% of total fuel combustion) of Middle income in 2005 to that in 2006?
Provide a succinct answer. 1.01. What is the ratio of the CO2 emissions (% of total fuel combustion) of North America in 2005 to that in 2006?
Give a very brief answer. 0.91. What is the ratio of the CO2 emissions (% of total fuel combustion) in New Zealand in 2005 to that in 2006?
Your answer should be very brief. 0.99. What is the ratio of the CO2 emissions (% of total fuel combustion) in Venezuela in 2005 to that in 2006?
Your answer should be compact. 8.64. What is the ratio of the CO2 emissions (% of total fuel combustion) in Middle income in 2005 to that in 2007?
Offer a very short reply. 1.06. What is the ratio of the CO2 emissions (% of total fuel combustion) of North America in 2005 to that in 2007?
Give a very brief answer. 0.97. What is the ratio of the CO2 emissions (% of total fuel combustion) of New Zealand in 2005 to that in 2007?
Keep it short and to the point. 1. What is the ratio of the CO2 emissions (% of total fuel combustion) of Venezuela in 2005 to that in 2007?
Give a very brief answer. 2.71. What is the ratio of the CO2 emissions (% of total fuel combustion) in Middle income in 2006 to that in 2007?
Provide a succinct answer. 1.05. What is the ratio of the CO2 emissions (% of total fuel combustion) in North America in 2006 to that in 2007?
Make the answer very short. 1.06. What is the ratio of the CO2 emissions (% of total fuel combustion) in New Zealand in 2006 to that in 2007?
Provide a succinct answer. 1.01. What is the ratio of the CO2 emissions (% of total fuel combustion) in Venezuela in 2006 to that in 2007?
Your answer should be very brief. 0.31. What is the difference between the highest and the second highest CO2 emissions (% of total fuel combustion) in Middle income?
Make the answer very short. 0. What is the difference between the highest and the second highest CO2 emissions (% of total fuel combustion) of North America?
Provide a short and direct response. 0.07. What is the difference between the highest and the second highest CO2 emissions (% of total fuel combustion) of New Zealand?
Keep it short and to the point. 0.04. What is the difference between the highest and the second highest CO2 emissions (% of total fuel combustion) in Venezuela?
Your answer should be compact. 0.48. What is the difference between the highest and the lowest CO2 emissions (% of total fuel combustion) in Middle income?
Ensure brevity in your answer.  0.21. What is the difference between the highest and the lowest CO2 emissions (% of total fuel combustion) of North America?
Offer a very short reply. 0.3. What is the difference between the highest and the lowest CO2 emissions (% of total fuel combustion) in New Zealand?
Keep it short and to the point. 0.5. What is the difference between the highest and the lowest CO2 emissions (% of total fuel combustion) in Venezuela?
Give a very brief answer. 0.8. 